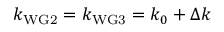Convert formula to latex. <formula><loc_0><loc_0><loc_500><loc_500>k _ { W G 2 } = k _ { W G 3 } = k _ { 0 } + \Delta k</formula> 